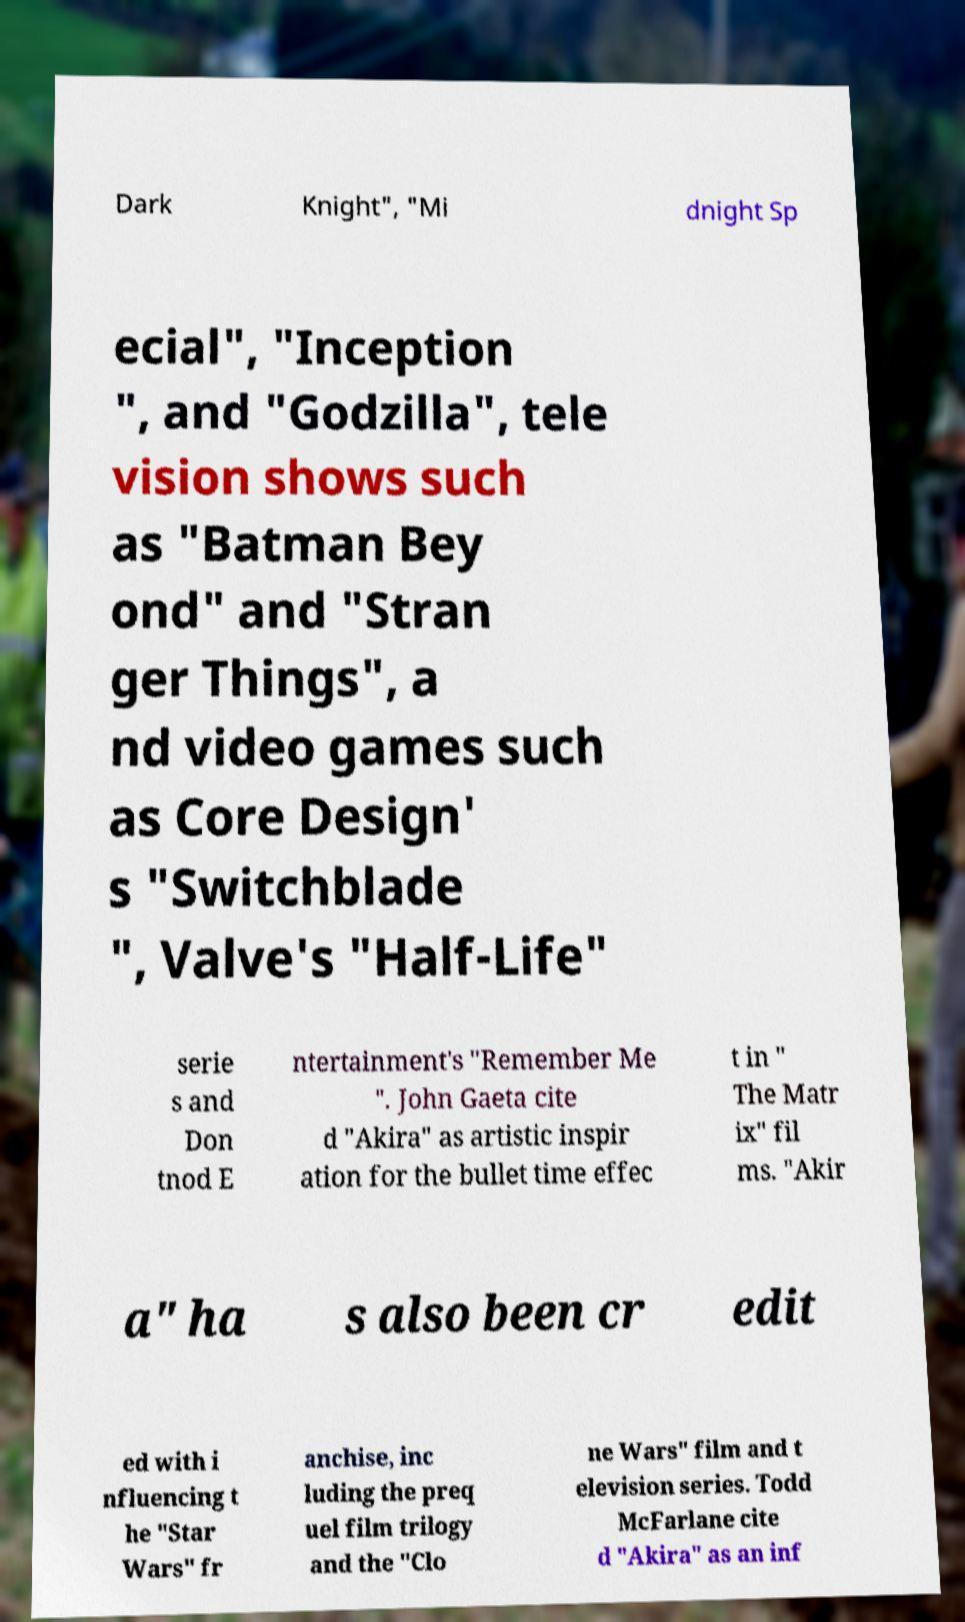There's text embedded in this image that I need extracted. Can you transcribe it verbatim? Dark Knight", "Mi dnight Sp ecial", "Inception ", and "Godzilla", tele vision shows such as "Batman Bey ond" and "Stran ger Things", a nd video games such as Core Design' s "Switchblade ", Valve's "Half-Life" serie s and Don tnod E ntertainment's "Remember Me ". John Gaeta cite d "Akira" as artistic inspir ation for the bullet time effec t in " The Matr ix" fil ms. "Akir a" ha s also been cr edit ed with i nfluencing t he "Star Wars" fr anchise, inc luding the preq uel film trilogy and the "Clo ne Wars" film and t elevision series. Todd McFarlane cite d "Akira" as an inf 